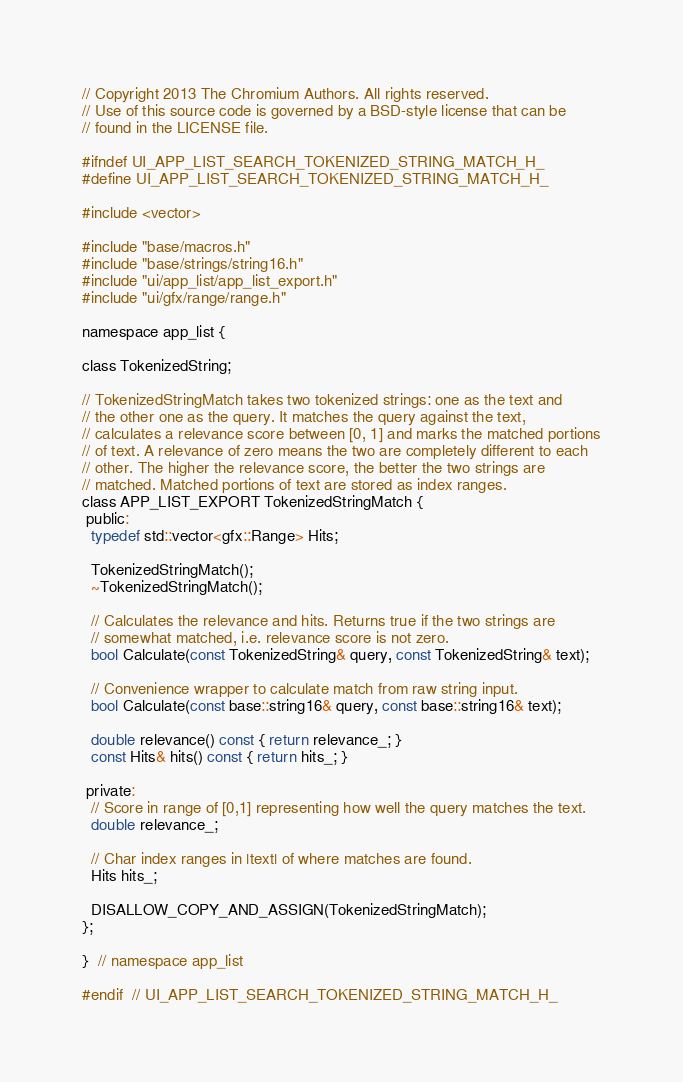Convert code to text. <code><loc_0><loc_0><loc_500><loc_500><_C_>// Copyright 2013 The Chromium Authors. All rights reserved.
// Use of this source code is governed by a BSD-style license that can be
// found in the LICENSE file.

#ifndef UI_APP_LIST_SEARCH_TOKENIZED_STRING_MATCH_H_
#define UI_APP_LIST_SEARCH_TOKENIZED_STRING_MATCH_H_

#include <vector>

#include "base/macros.h"
#include "base/strings/string16.h"
#include "ui/app_list/app_list_export.h"
#include "ui/gfx/range/range.h"

namespace app_list {

class TokenizedString;

// TokenizedStringMatch takes two tokenized strings: one as the text and
// the other one as the query. It matches the query against the text,
// calculates a relevance score between [0, 1] and marks the matched portions
// of text. A relevance of zero means the two are completely different to each
// other. The higher the relevance score, the better the two strings are
// matched. Matched portions of text are stored as index ranges.
class APP_LIST_EXPORT TokenizedStringMatch {
 public:
  typedef std::vector<gfx::Range> Hits;

  TokenizedStringMatch();
  ~TokenizedStringMatch();

  // Calculates the relevance and hits. Returns true if the two strings are
  // somewhat matched, i.e. relevance score is not zero.
  bool Calculate(const TokenizedString& query, const TokenizedString& text);

  // Convenience wrapper to calculate match from raw string input.
  bool Calculate(const base::string16& query, const base::string16& text);

  double relevance() const { return relevance_; }
  const Hits& hits() const { return hits_; }

 private:
  // Score in range of [0,1] representing how well the query matches the text.
  double relevance_;

  // Char index ranges in |text| of where matches are found.
  Hits hits_;

  DISALLOW_COPY_AND_ASSIGN(TokenizedStringMatch);
};

}  // namespace app_list

#endif  // UI_APP_LIST_SEARCH_TOKENIZED_STRING_MATCH_H_
</code> 